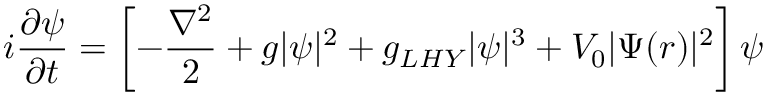<formula> <loc_0><loc_0><loc_500><loc_500>i \frac { \partial \psi } { \partial t } = \left [ - \frac { \nabla ^ { 2 } } { 2 } + g | \psi | ^ { 2 } + g _ { L H Y } | \psi | ^ { 3 } + V _ { 0 } | \Psi ( r ) | ^ { 2 } \right ] \psi</formula> 